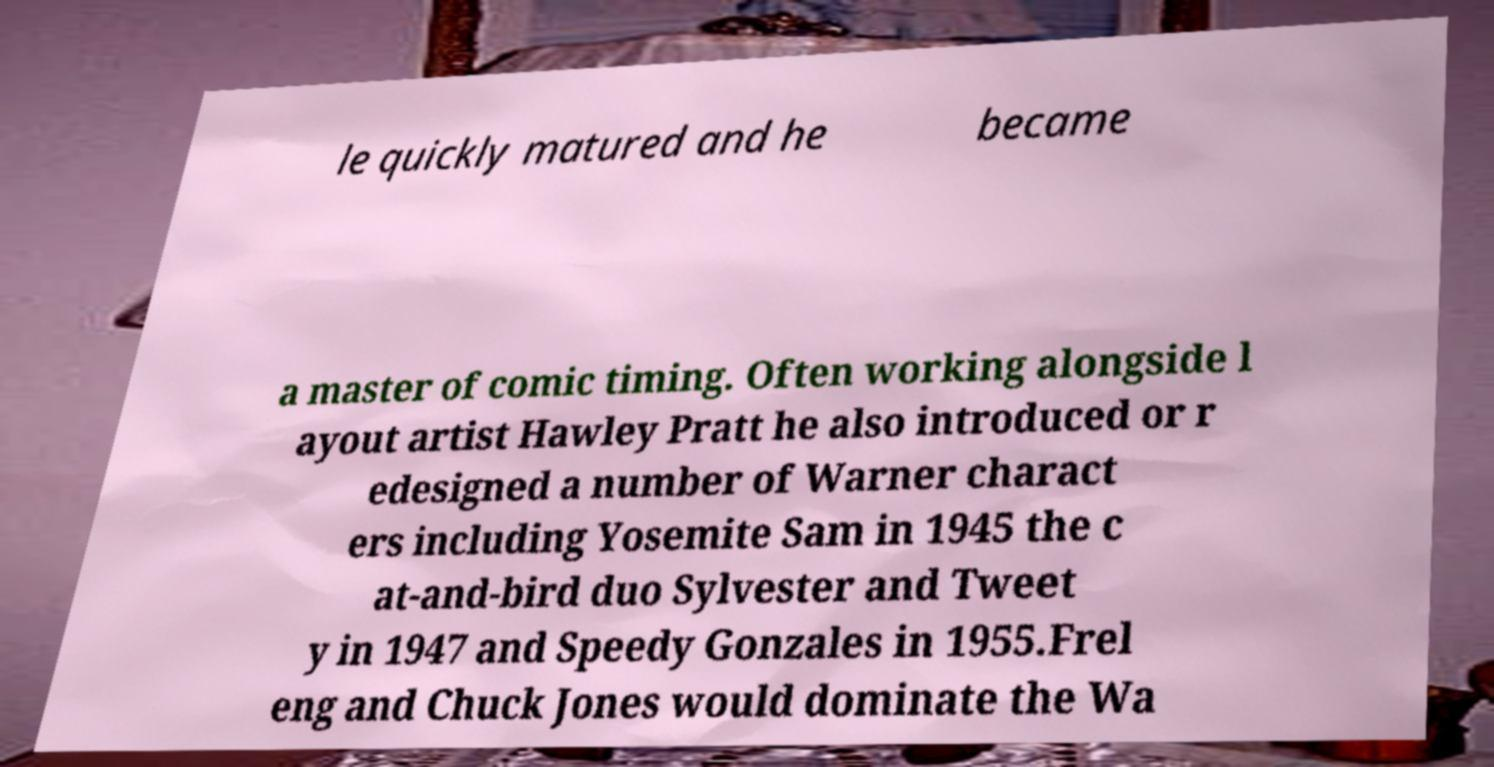Could you assist in decoding the text presented in this image and type it out clearly? le quickly matured and he became a master of comic timing. Often working alongside l ayout artist Hawley Pratt he also introduced or r edesigned a number of Warner charact ers including Yosemite Sam in 1945 the c at-and-bird duo Sylvester and Tweet y in 1947 and Speedy Gonzales in 1955.Frel eng and Chuck Jones would dominate the Wa 